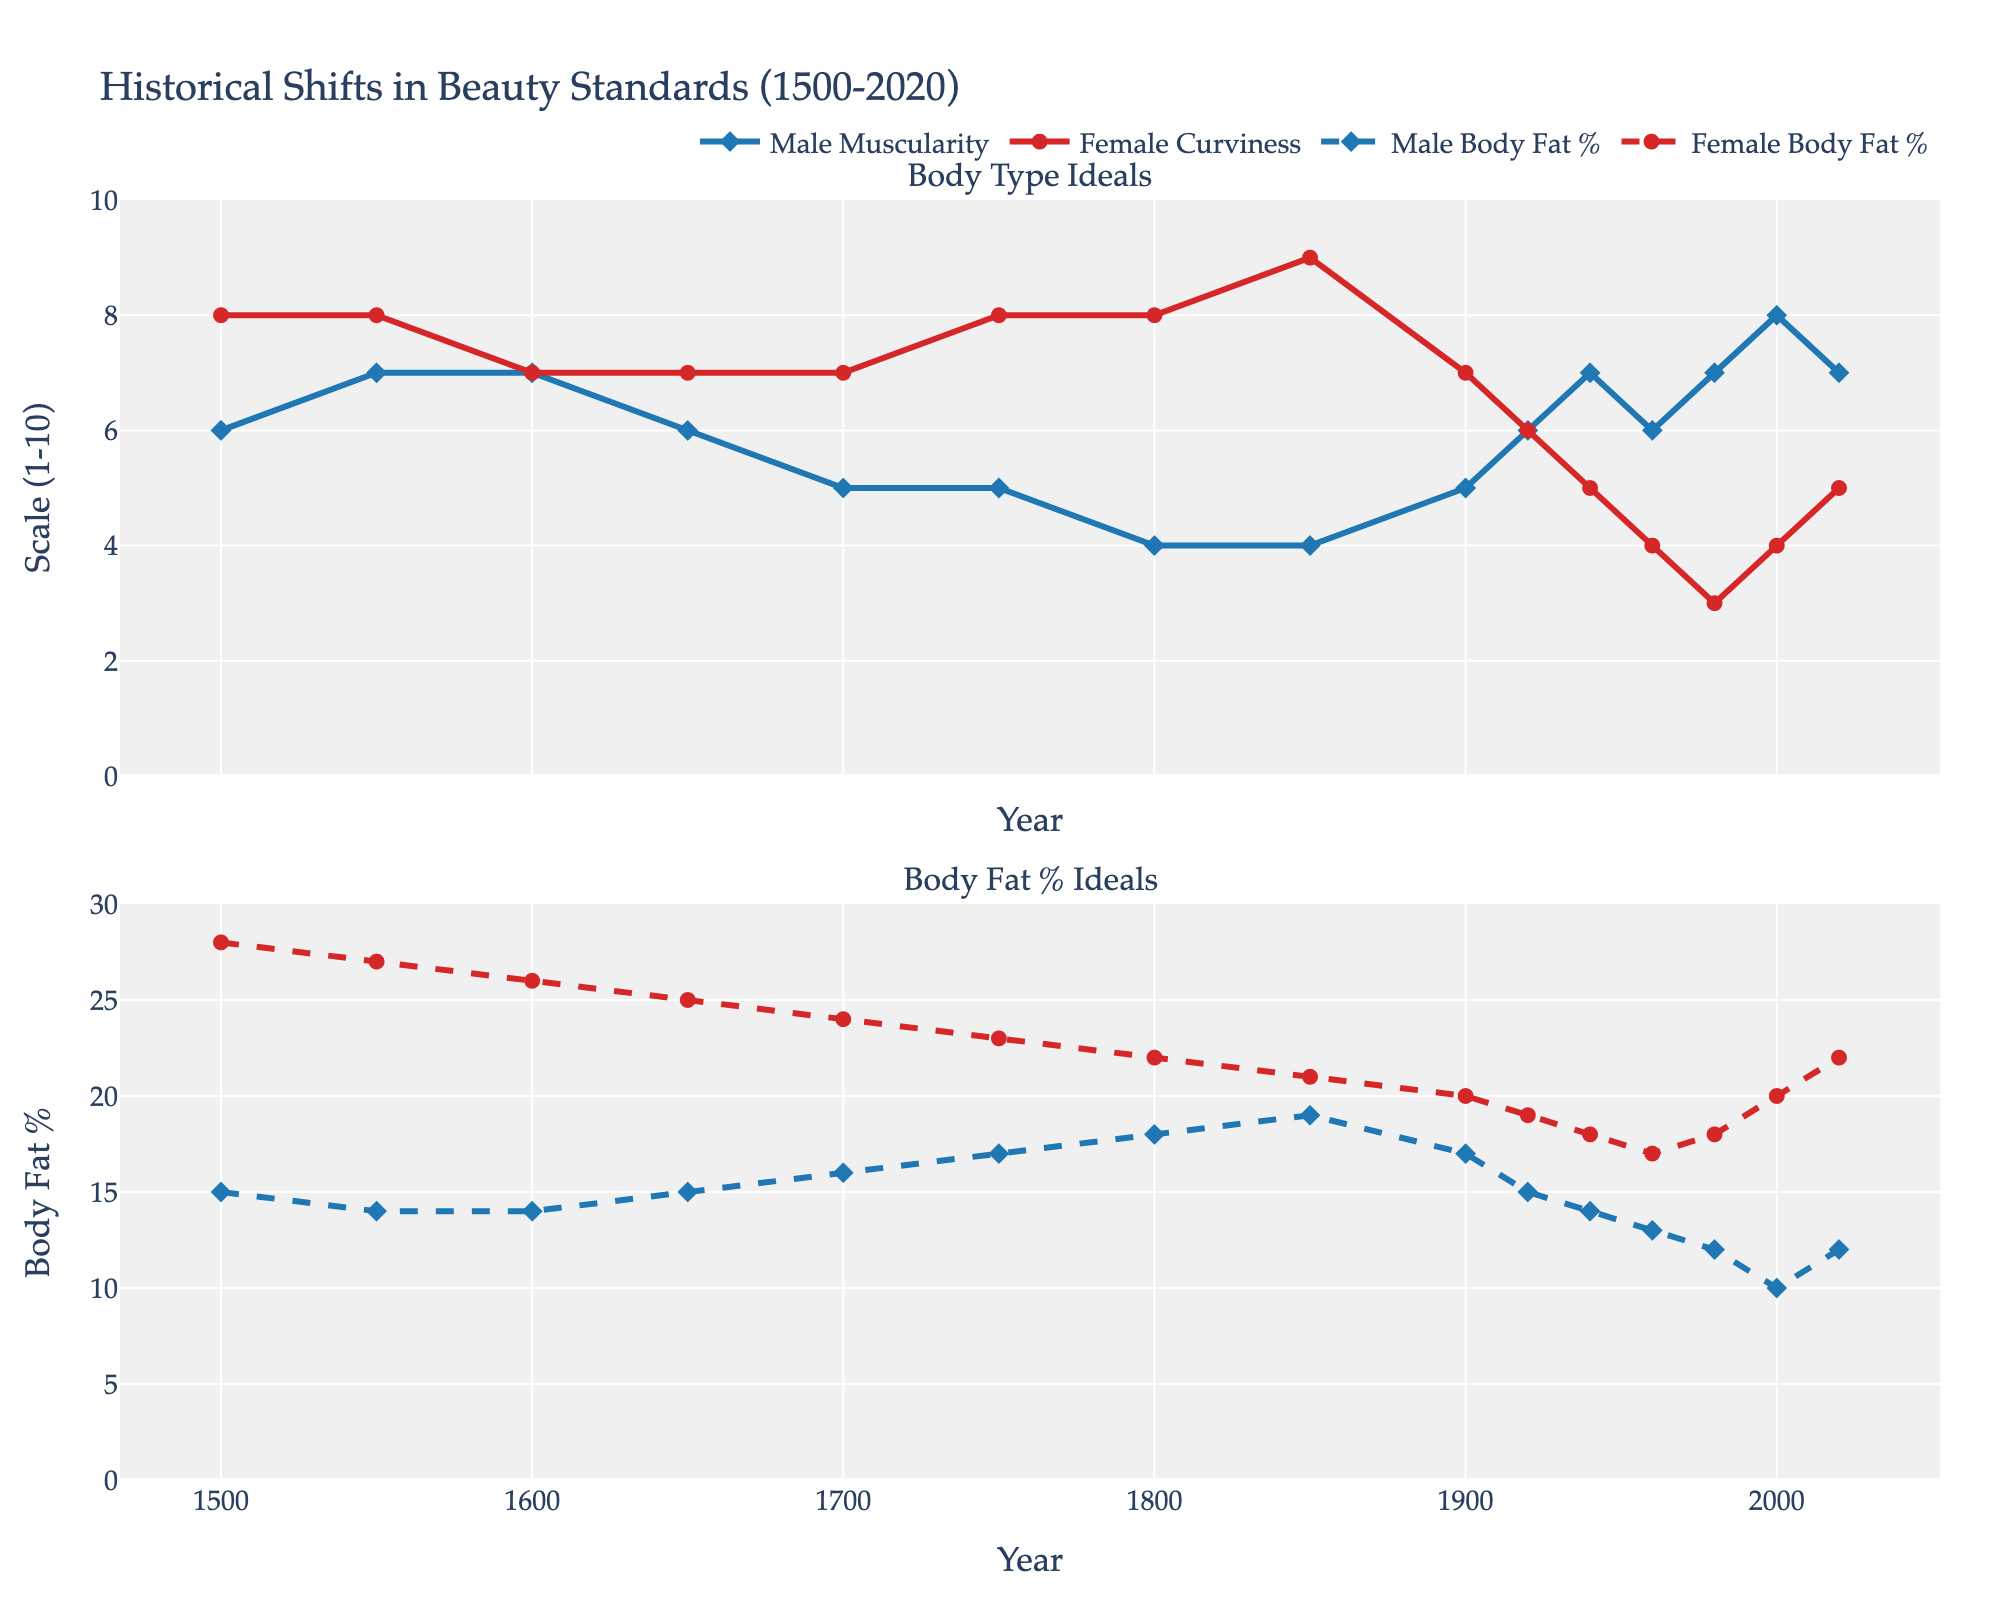How has male muscularity changed from 1500 to 2000? Compare the values of male muscularity at 1500 and 2000. In 1500, male muscularity is 6. By 2000, it has increased to 8. The increase is 8 - 6 = 2.
Answer: It has increased by 2 What is the difference between female curviness in 1800 and in 1960? Look at the values for female curviness in 1800 and 1960. In 1800, it's 8. In 1960, it's 4. The difference is 8 - 4 = 4.
Answer: 4 In which year did male body fat percentage ideal peak, and what was the value? Identify the year with the highest value for the male body fat percentage ideal. The peak occurred in 1850 with a value of 19%.
Answer: 1850, 19% Was female body fat percentage ideal ever lower than male body fat percentage ideal? Compare the lines representing male and female body fat percentage ideals across the years. At no point in the graph does the female body fat percentage ideal dip below the male body fat percentage ideal.
Answer: No What's the average male muscularity score from 1900 to 2020? Add up the values for male muscularity from 1900 (5), 1920 (6), 1940 (7), 1960 (6), 1980 (7), 2000 (8), and 2020 (7). The sum is 5 + 6 + 7 + 6 + 7 + 8 + 7 = 46. There are 7 data points, so the average is 46 / 7 ≈ 6.57.
Answer: Approximately 6.57 During which period did female curviness decrease the most sharply? Observe the trend of female curviness from year-to-year. The most significant drop occurred between 1850 (9) and 1920 (6), decreasing by 3 points.
Answer: Between 1850 and 1920 Which gender's body fat percentage ideal started decreasing first, and when? Compare the trends of both male and female body fat percentage ideals over the years. The male body fat percentage ideal started decreasing first around 1700, followed by the female body fat percentage ideal starting around 1750.
Answer: Male, around 1700 How have the male and female body fat percentage ideals converged or diverged over time? Observe the patterns of male and female body fat percentage ideals. They started off with a larger gap (13% difference in 1500) but gradually decreased. The closest convergence is 12% in 1980, and the gap widened again to 10% by 2020.
Answer: Converged then diverged In which century did both male muscularity and female curviness have values closer to the middle of the scale (5-6)? Check the values for male muscularity and female curviness in each century. In the 20th century, female curviness was around 6 (1920) and male muscularity around 5-6, fitting the middle range.
Answer: 20th century 